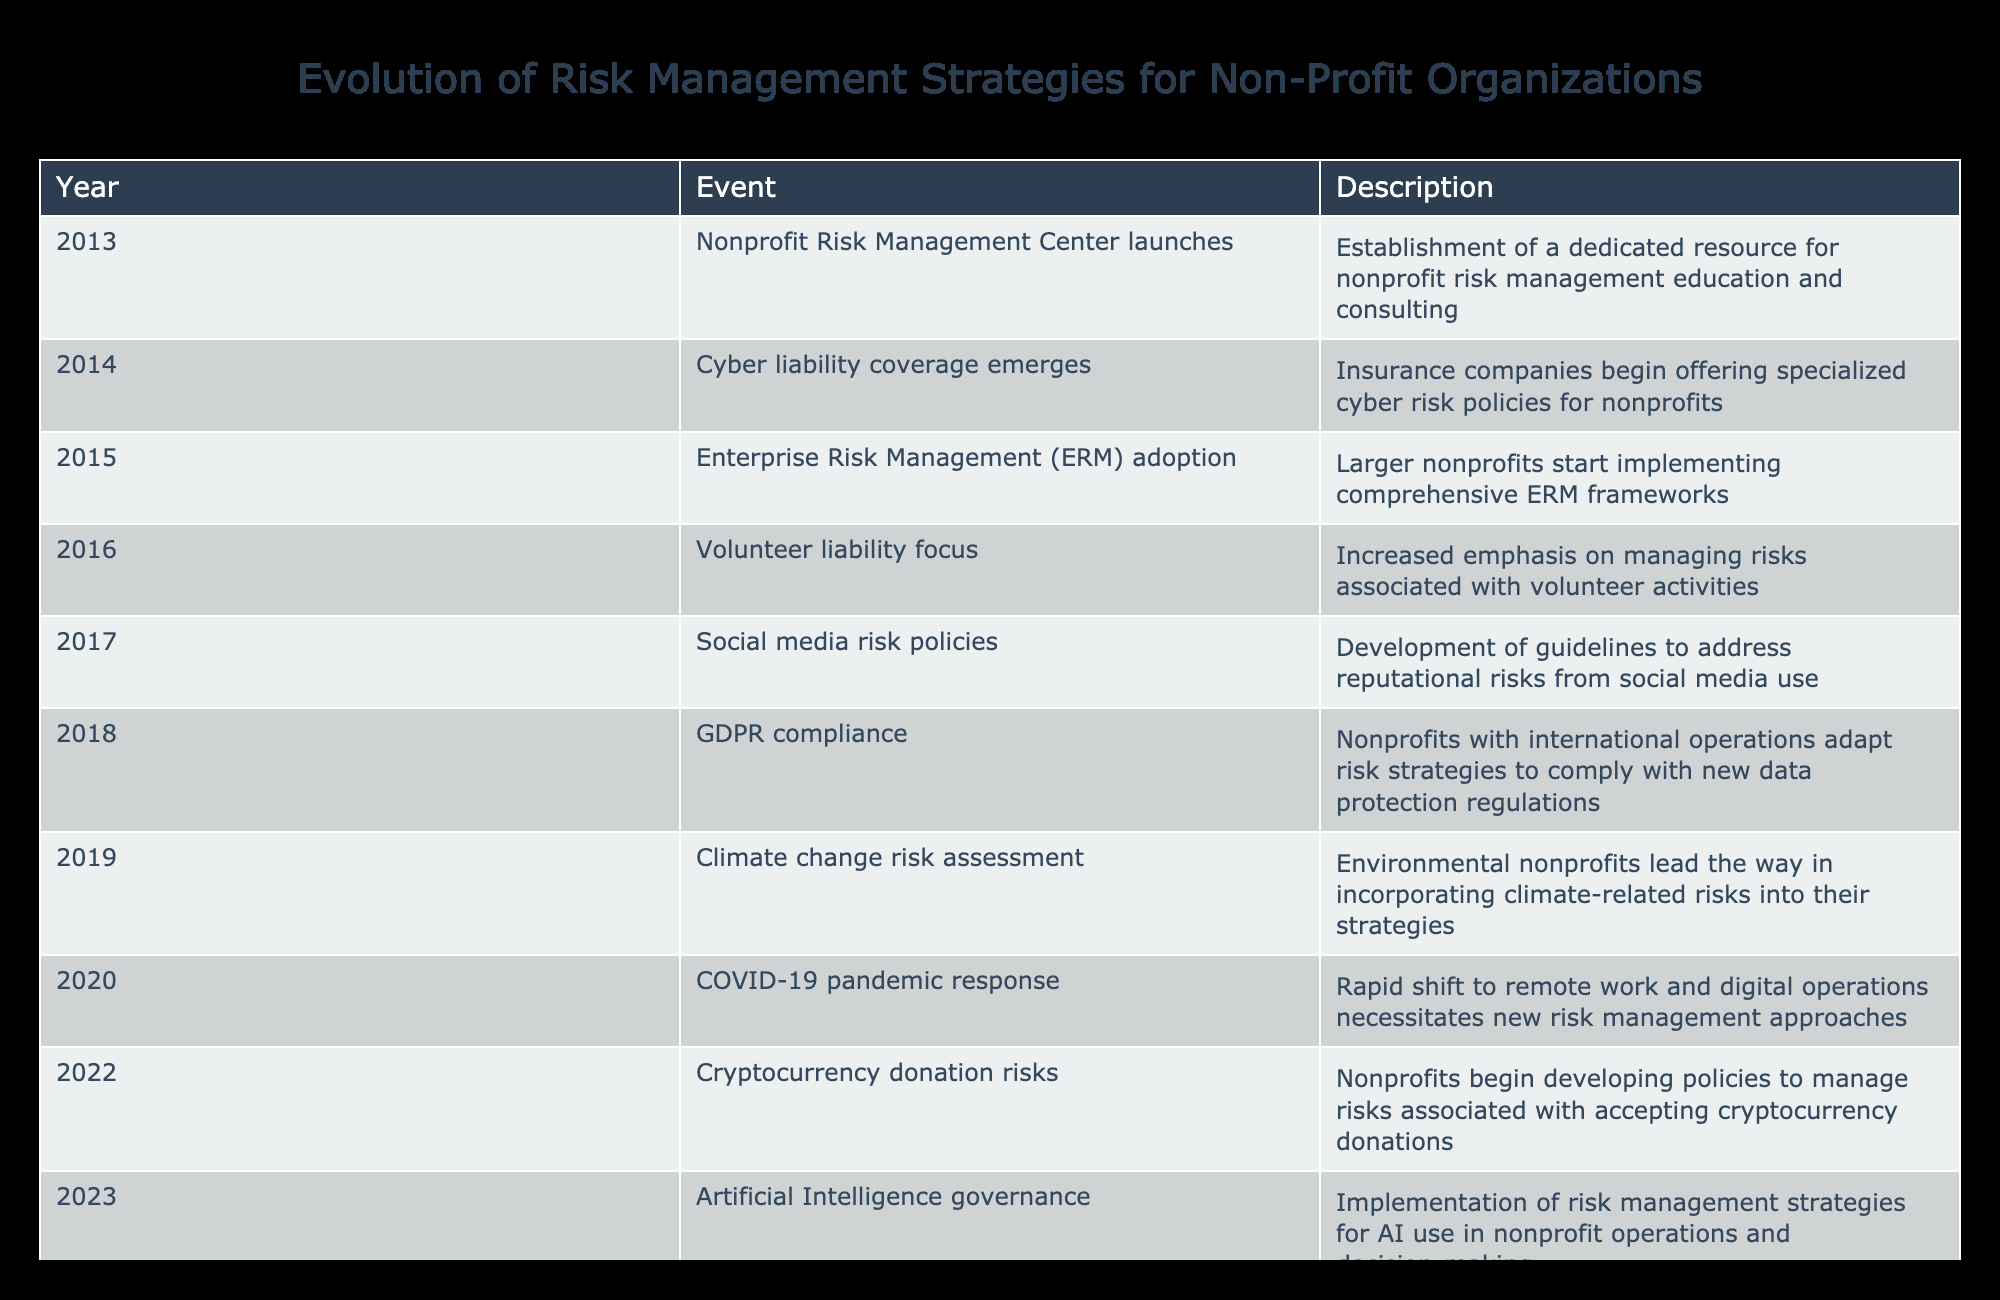What year did the Nonprofit Risk Management Center launch? The table explicitly states that the Nonprofit Risk Management Center was launched in 2013, as shown in the "Event" column.
Answer: 2013 In which year did nonprofits start focusing on cryptocurrency donation risks? The table indicates that the development of policies related to cryptocurrency donation risks began in 2022, as this specific event is listed for that year.
Answer: 2022 How many years did it take from the launch of the Nonprofit Risk Management Center to the implementation of Artificial Intelligence governance strategies? The center launched in 2013 and AI governance strategies were implemented in 2023. The time elapsed is 2023 - 2013 = 10 years.
Answer: 10 years Did nonprofits begin to address social media risks before or after the COVID-19 pandemic? The development of social media risk policies occurred in 2017, while the COVID-19 pandemic response was noted in 2020. Thus, nonprofits began to address social media risks before the pandemic started.
Answer: Before What significant event related to GDPR compliance occurred for nonprofits in 2018? The table highlights that in 2018, nonprofits adapted their risk strategies to comply with GDPR, which is a significant development concerning data protection and privacy regulations.
Answer: GDPR compliance adaptation What was the first event listed in the timeline related to nonprofit risk management strategies? The first event listed in the timeline is the launch of the Nonprofit Risk Management Center in 2013, indicating the start of focused resource and consultation for risk management.
Answer: Nonprofit Risk Management Center launches List the total number of significant events related to risk management strategies in the table provided. Counting each event from 2013 to 2023 listed in the table, there are 10 distinct events that relate to the evolution of risk management strategies for nonprofits.
Answer: 10 events Which two years saw significant focus on risks associated with digital transactions (both remote work and cryptocurrency)? The years 2020 and 2022 are where significant focus on digital transactions occurred: 2020 indicated a shift to remote work due to COVID-19, while 2022 referenced the acceptance of cryptocurrency donations.
Answer: 2020 and 2022 